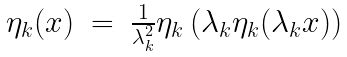<formula> <loc_0><loc_0><loc_500><loc_500>\begin{array} { r c l } \eta _ { k } ( x ) & = & \frac { 1 } { \lambda _ { k } ^ { 2 } } \eta _ { k } \left ( \lambda _ { k } \eta _ { k } ( \lambda _ { k } x ) \right ) \end{array}</formula> 